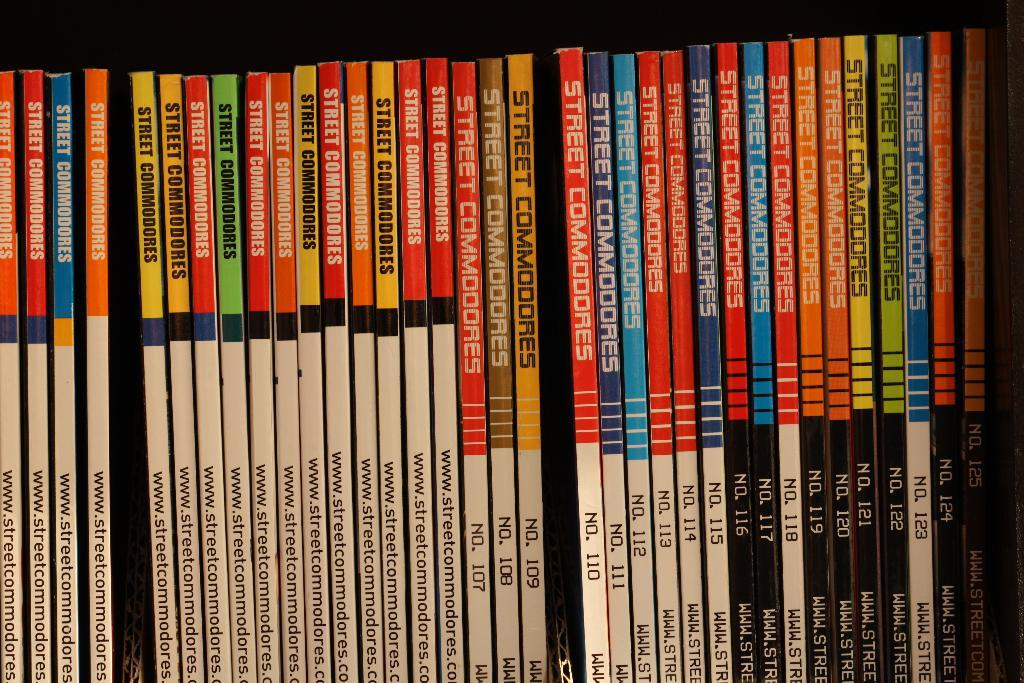<image>
Provide a brief description of the given image. Slender volumes of Street Commodores books are lined up. 